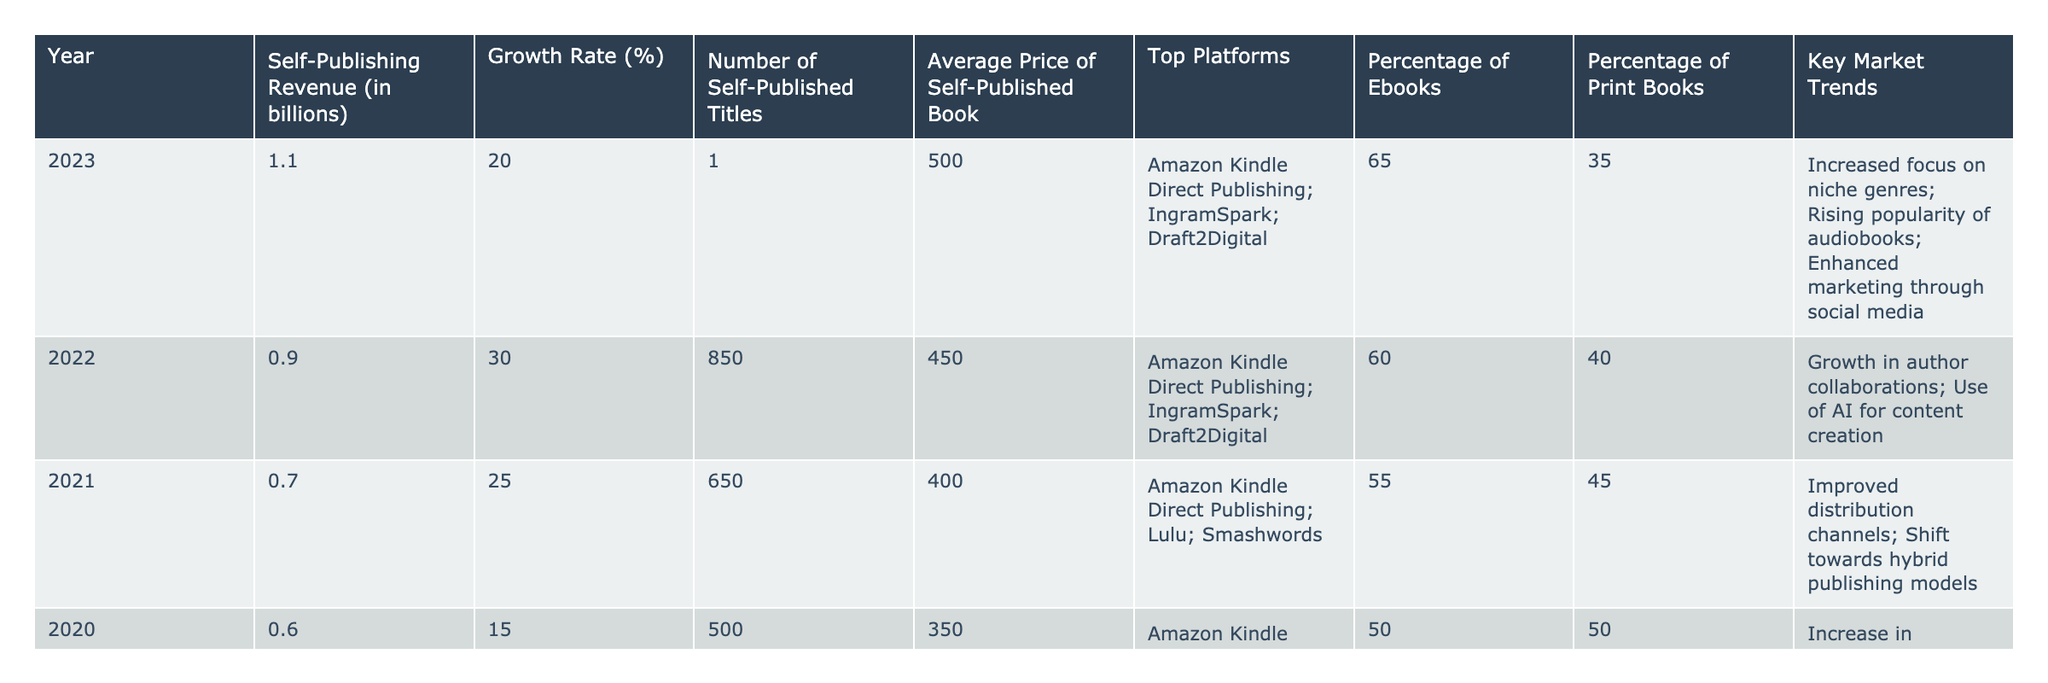What was the self-publishing revenue in 2023? The table shows that the self-publishing revenue in 2023 was 1.1 billion.
Answer: 1.1 billion What is the growth rate of self-publishing revenue from 2022 to 2023? The growth rate for 2023 is 20% and for 2022 it is 30%. The growth rate from 2022 to 2023 is not directly calculable as we're comparing the growth rates of two consecutive years rather than revenue figures. Thus, it remains a fact that the growth rate decreased.
Answer: N/A Which year had the highest number of self-published titles? Looking across the years in the table, 2022 had the highest number of self-published titles at 850.
Answer: 2022 What is the average price of a self-published book in 2023 compared to 2021? The average price in 2023 is 500, while in 2021 it was 400. The difference between the two prices is 500 - 400 = 100.
Answer: 100 Did the percentage of eBooks increase from 2019 to 2021? In 2019, the percentage of eBooks was 45%, and in 2021 it was 55%. This indicates an increase.
Answer: Yes What is the trend in the average price of self-published books from 2019 to 2023? The average price increased from 300 in 2019 to 500 in 2023. Thus, the trend is an upward trend with an increase of 200 over the 5 years.
Answer: Upward trend How much did self-publishing revenue grow from 2020 to 2023? Revenue in 2020 was 0.6 billion and in 2023 was 1.1 billion. The growth is calculated as 1.1 - 0.6 = 0.5 billion.
Answer: 0.5 billion What percentage of self-published titles in 2023 were eBooks? The table states that in 2023, 65% of self-published titles were eBooks.
Answer: 65% Is the growth rate of self-publishing higher in 2022 than in 2023? The growth rate was 30% in 2022 and 20% in 2023, showing a decrease.
Answer: Yes What was the average price per self-published book in 2022? The average price in 2022 was 450 according to the table.
Answer: 450 